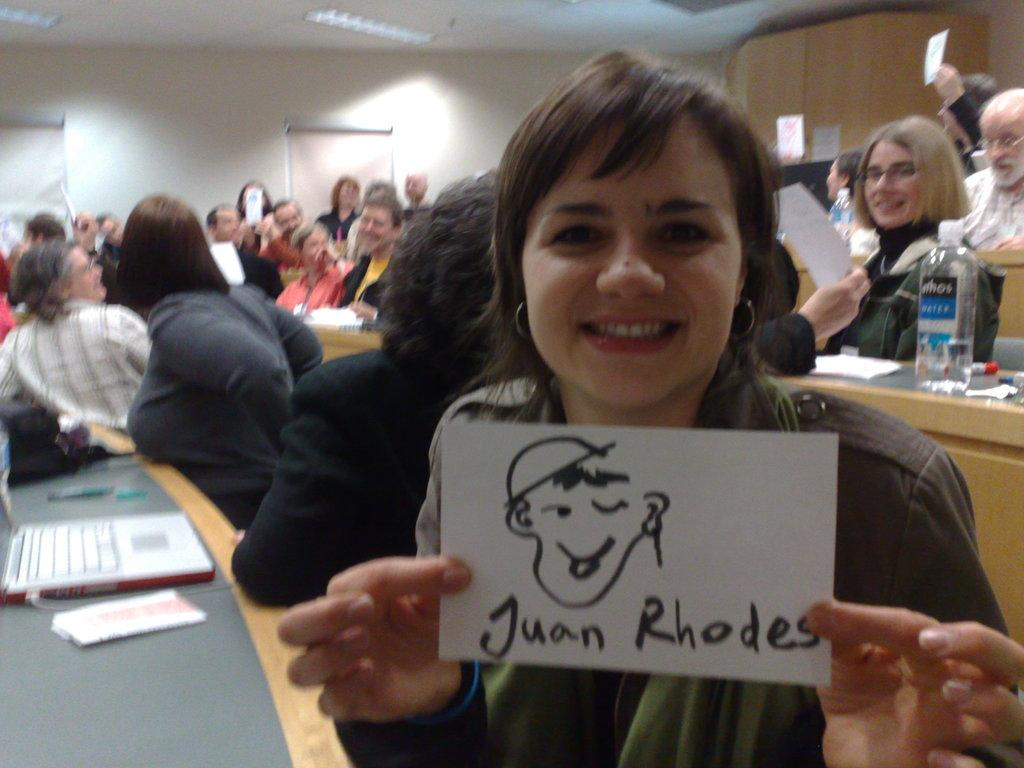How many people are in the image? There is a group of people in the image. What are the people doing in the image? The people are sitting on chairs. What objects can be seen in the image besides the people? There is a bottle, a laptop, and a paper on the table in the image. What type of farming equipment can be seen in the image? There is no farming equipment present in the image. How many brothers are visible in the image? There is no mention of brothers in the image; it features a group of people sitting on chairs. 